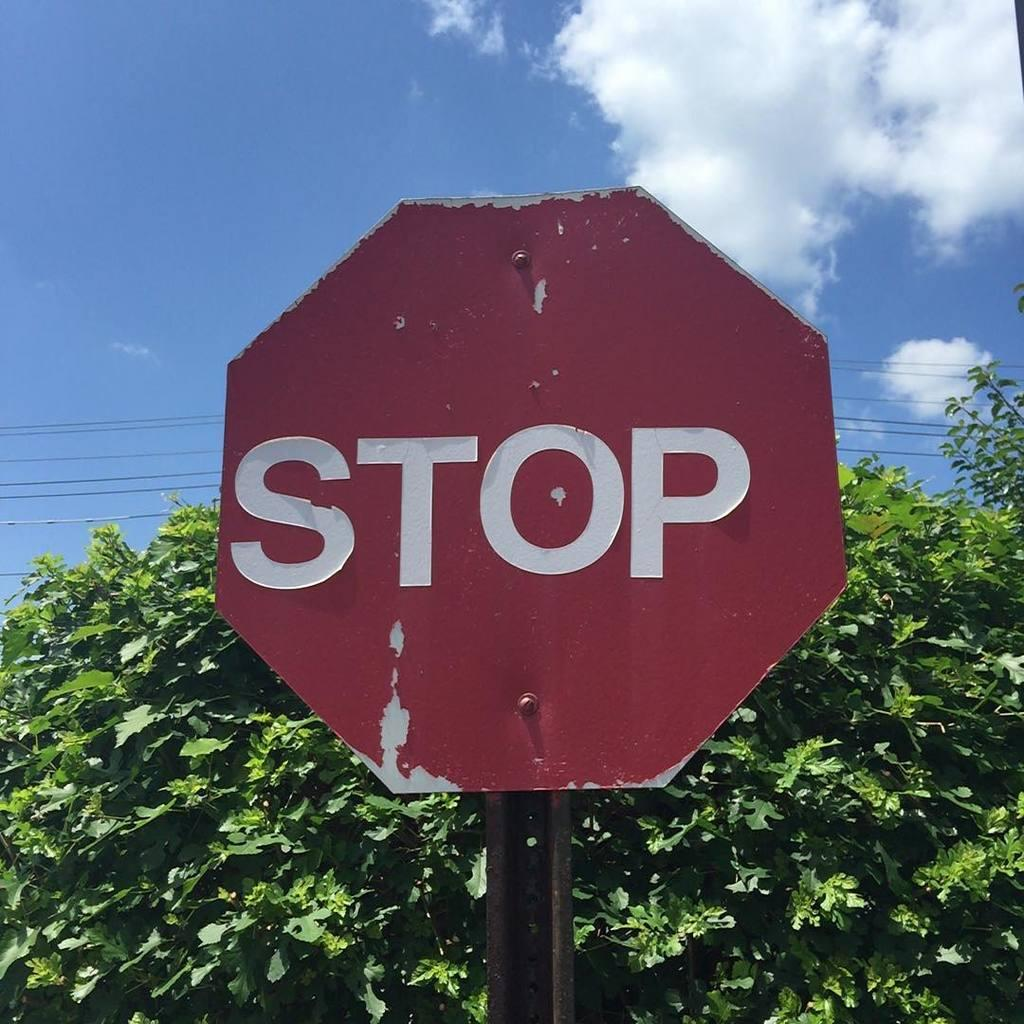Provide a one-sentence caption for the provided image. A red sign with STOP in white letters posted in front of a tree. 